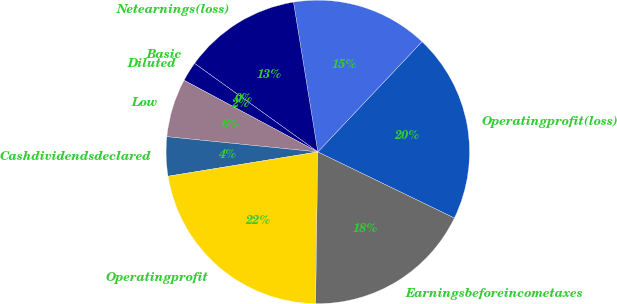Convert chart to OTSL. <chart><loc_0><loc_0><loc_500><loc_500><pie_chart><fcel>Operatingprofit(loss)<fcel>Unnamed: 1<fcel>Netearnings(loss)<fcel>Basic<fcel>Diluted<fcel>Low<fcel>Cashdividendsdeclared<fcel>Operatingprofit<fcel>Earningsbeforeincometaxes<nl><fcel>20.13%<fcel>14.61%<fcel>12.53%<fcel>0.0%<fcel>2.08%<fcel>6.23%<fcel>4.16%<fcel>22.21%<fcel>18.05%<nl></chart> 